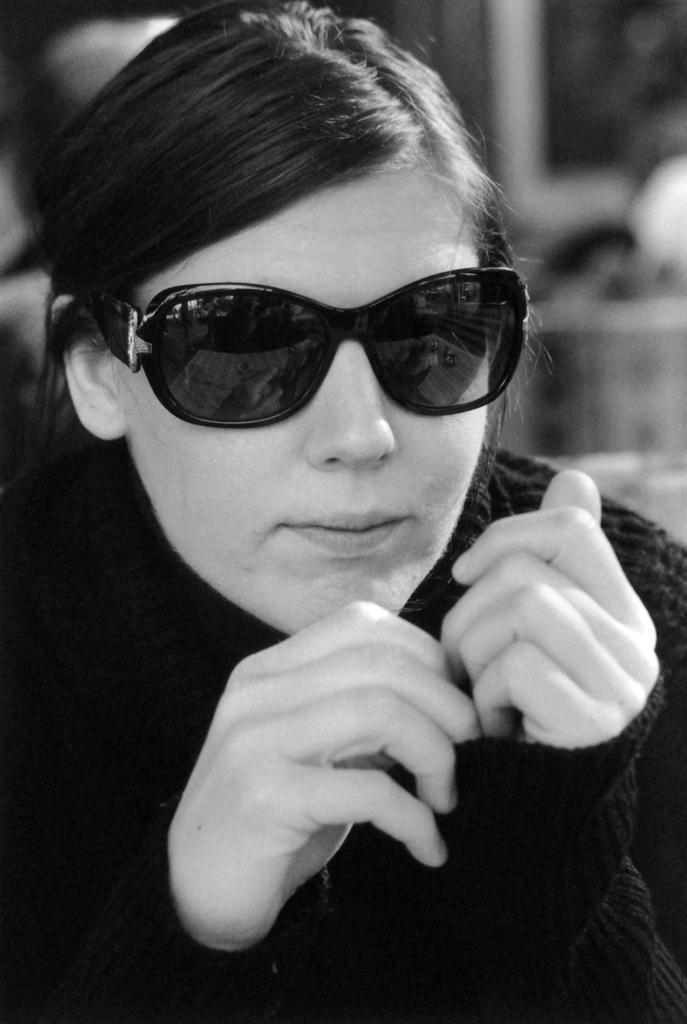How would you summarize this image in a sentence or two? This is a black and white image. This image consists of a woman. She is wearing goggles. 